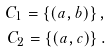Convert formula to latex. <formula><loc_0><loc_0><loc_500><loc_500>C _ { 1 } = \left \{ ( a , b ) \right \} , \\ C _ { 2 } = \left \{ ( a , c ) \right \} .</formula> 